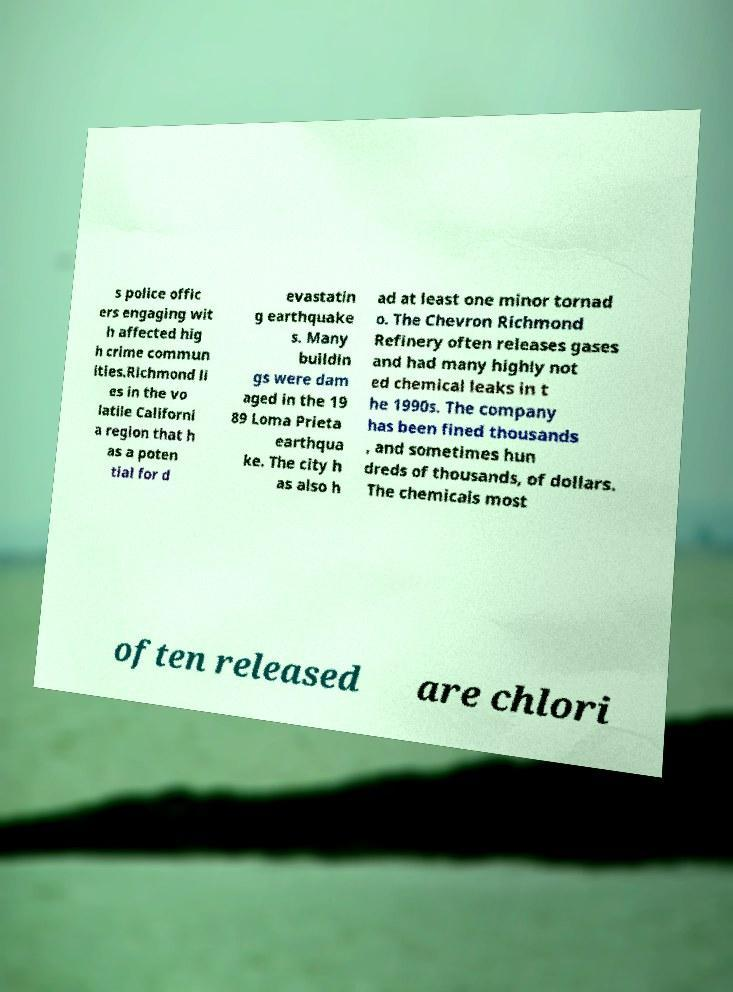For documentation purposes, I need the text within this image transcribed. Could you provide that? s police offic ers engaging wit h affected hig h crime commun ities.Richmond li es in the vo latile Californi a region that h as a poten tial for d evastatin g earthquake s. Many buildin gs were dam aged in the 19 89 Loma Prieta earthqua ke. The city h as also h ad at least one minor tornad o. The Chevron Richmond Refinery often releases gases and had many highly not ed chemical leaks in t he 1990s. The company has been fined thousands , and sometimes hun dreds of thousands, of dollars. The chemicals most often released are chlori 